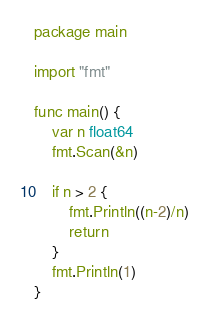<code> <loc_0><loc_0><loc_500><loc_500><_Go_>package main

import "fmt"

func main() {
	var n float64
	fmt.Scan(&n)

	if n > 2 {
		fmt.Println((n-2)/n)
		return
	}
	fmt.Println(1)
}
</code> 